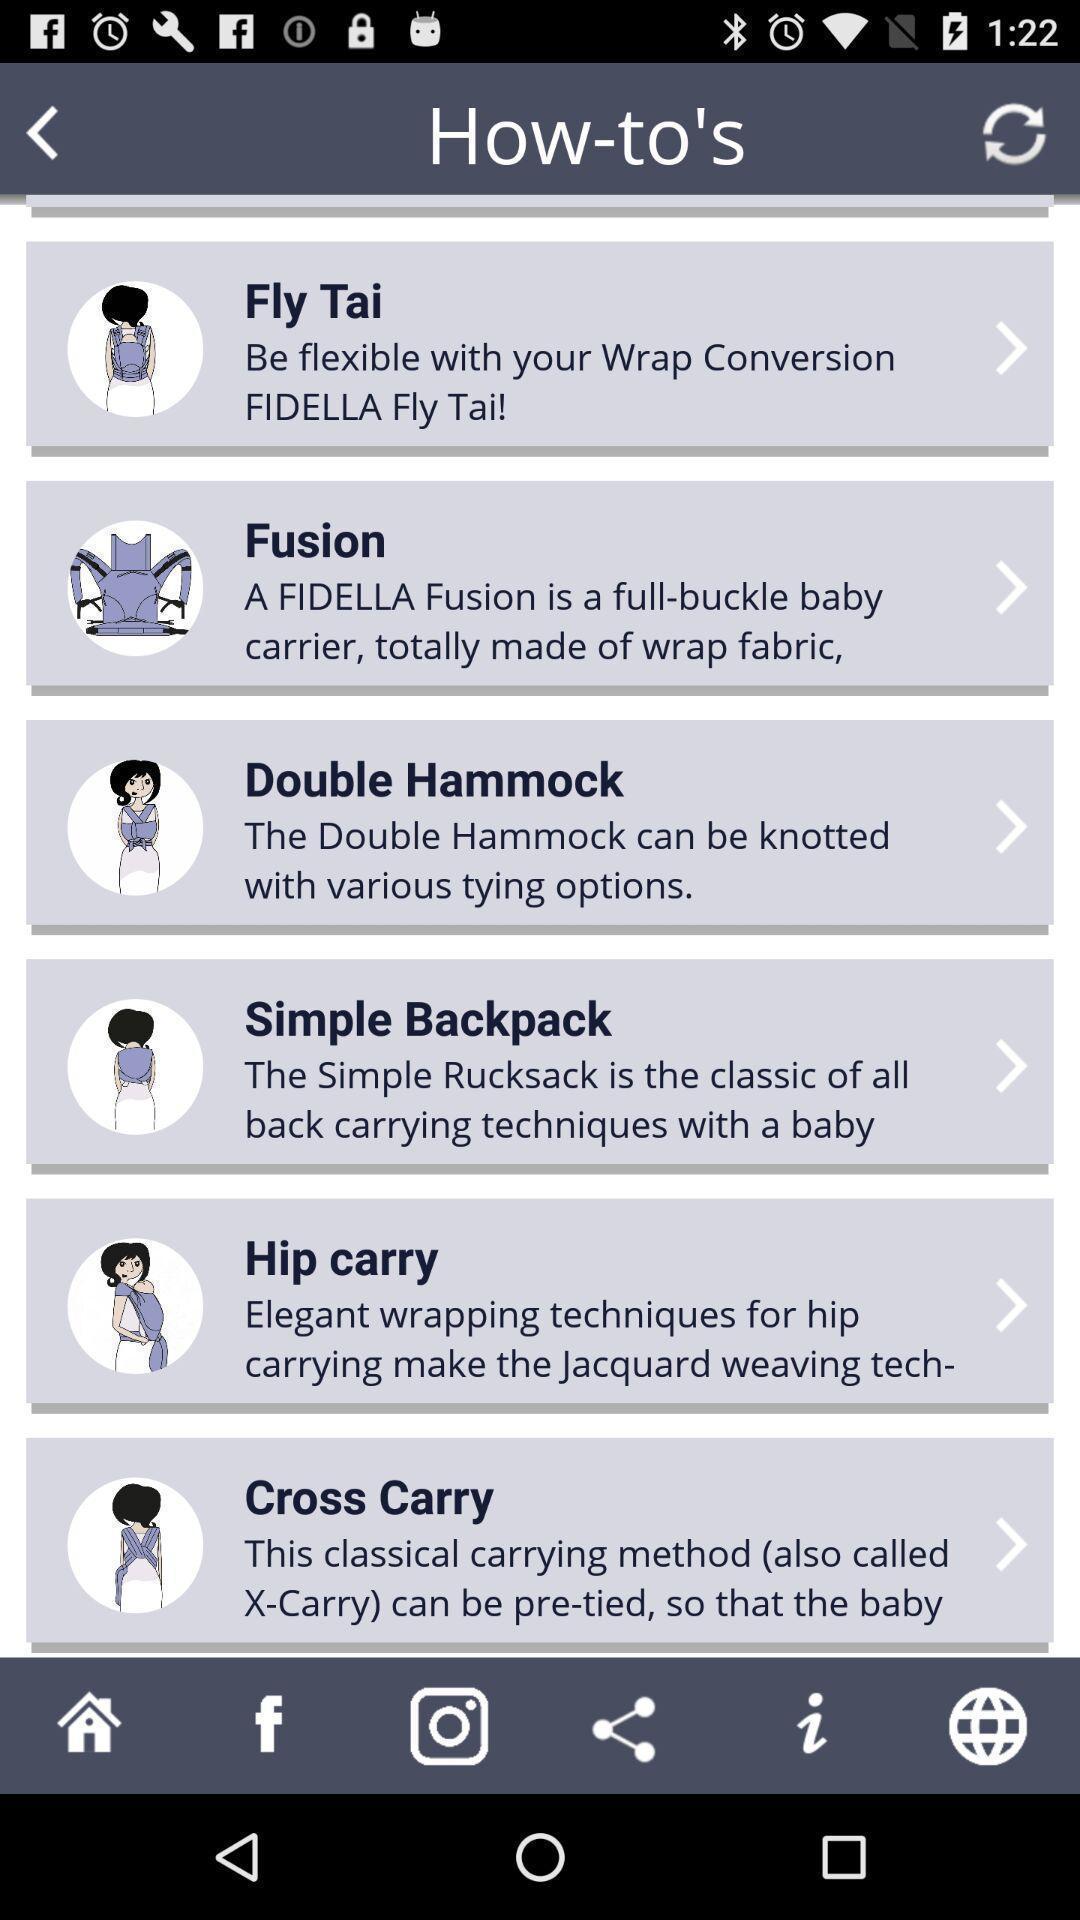Tell me what you see in this picture. Page displaying with different options to carry baby. 